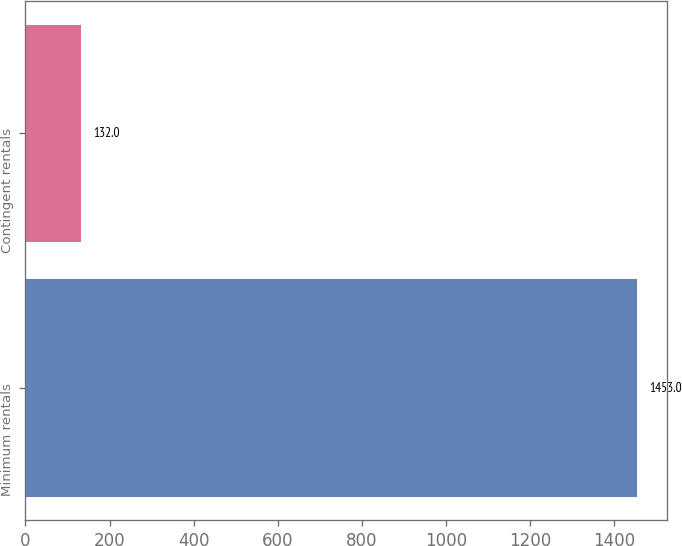Convert chart to OTSL. <chart><loc_0><loc_0><loc_500><loc_500><bar_chart><fcel>Minimum rentals<fcel>Contingent rentals<nl><fcel>1453<fcel>132<nl></chart> 